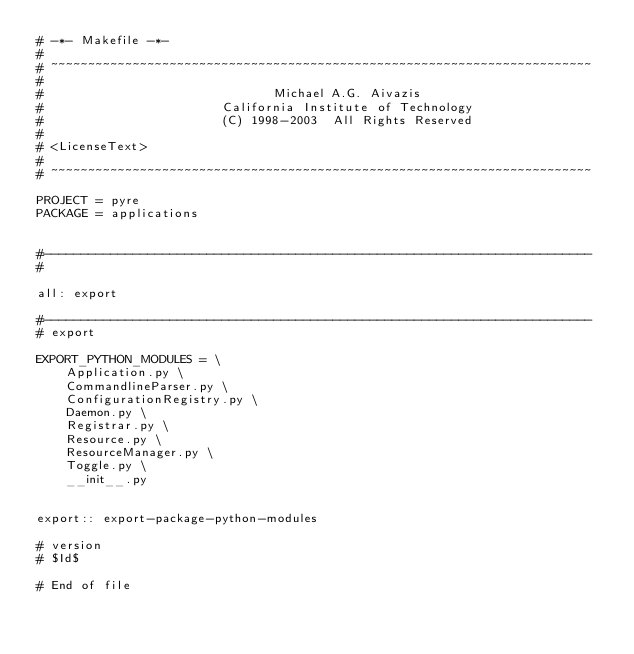<code> <loc_0><loc_0><loc_500><loc_500><_ObjectiveC_># -*- Makefile -*-
#
# ~~~~~~~~~~~~~~~~~~~~~~~~~~~~~~~~~~~~~~~~~~~~~~~~~~~~~~~~~~~~~~~~~~~~~~~~~
#
#                               Michael A.G. Aivazis
#                        California Institute of Technology
#                        (C) 1998-2003  All Rights Reserved
#
# <LicenseText>
#
# ~~~~~~~~~~~~~~~~~~~~~~~~~~~~~~~~~~~~~~~~~~~~~~~~~~~~~~~~~~~~~~~~~~~~~~~~~

PROJECT = pyre
PACKAGE = applications


#--------------------------------------------------------------------------
#

all: export

#--------------------------------------------------------------------------
# export

EXPORT_PYTHON_MODULES = \
    Application.py \
    CommandlineParser.py \
    ConfigurationRegistry.py \
    Daemon.py \
    Registrar.py \
    Resource.py \
    ResourceManager.py \
    Toggle.py \
    __init__.py


export:: export-package-python-modules

# version
# $Id$

# End of file
</code> 